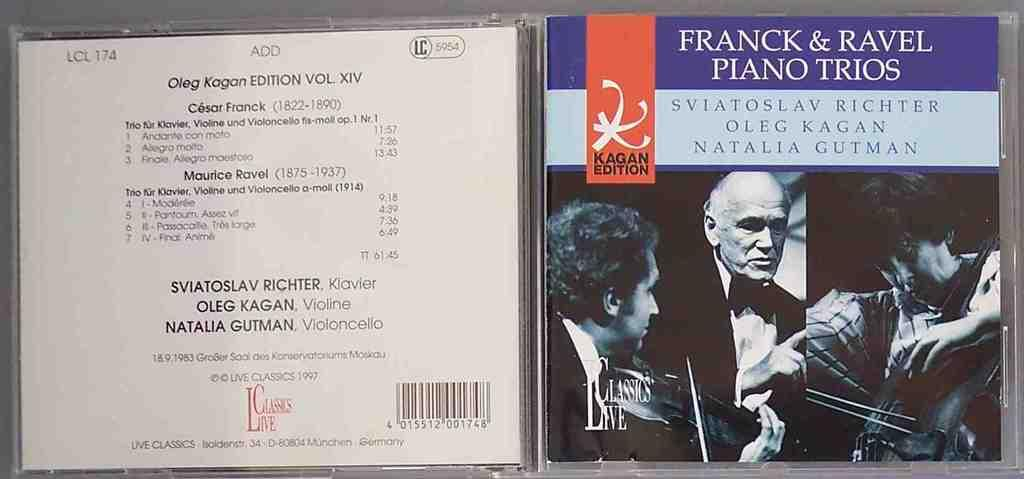<image>
Share a concise interpretation of the image provided. A CD of the group Franck & Ravel, piano trios 